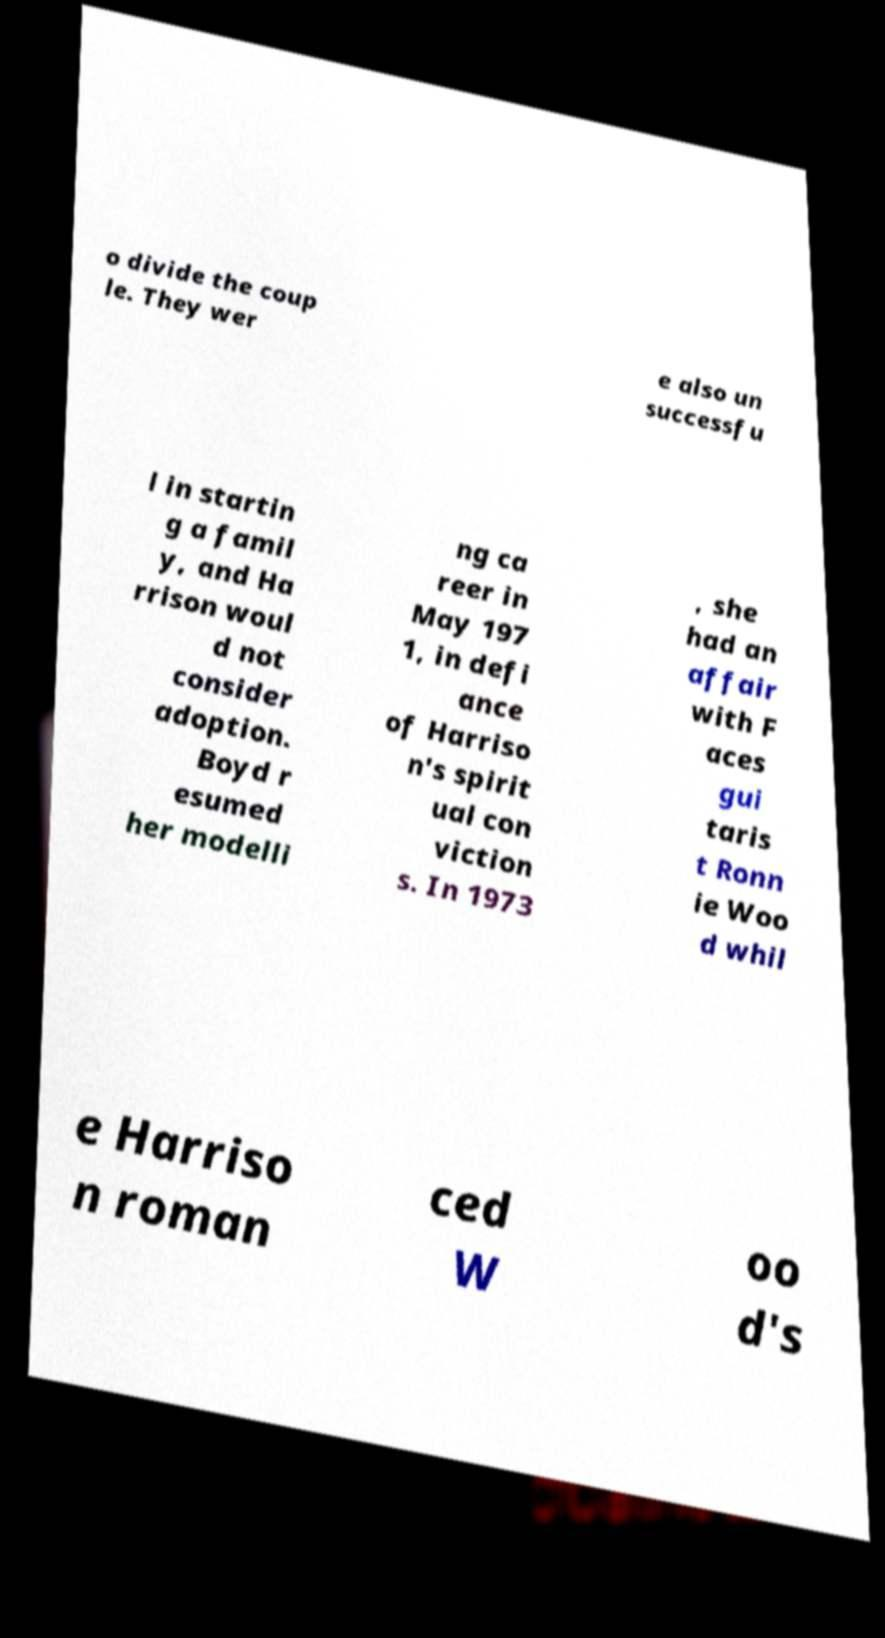Please identify and transcribe the text found in this image. o divide the coup le. They wer e also un successfu l in startin g a famil y, and Ha rrison woul d not consider adoption. Boyd r esumed her modelli ng ca reer in May 197 1, in defi ance of Harriso n's spirit ual con viction s. In 1973 , she had an affair with F aces gui taris t Ronn ie Woo d whil e Harriso n roman ced W oo d's 